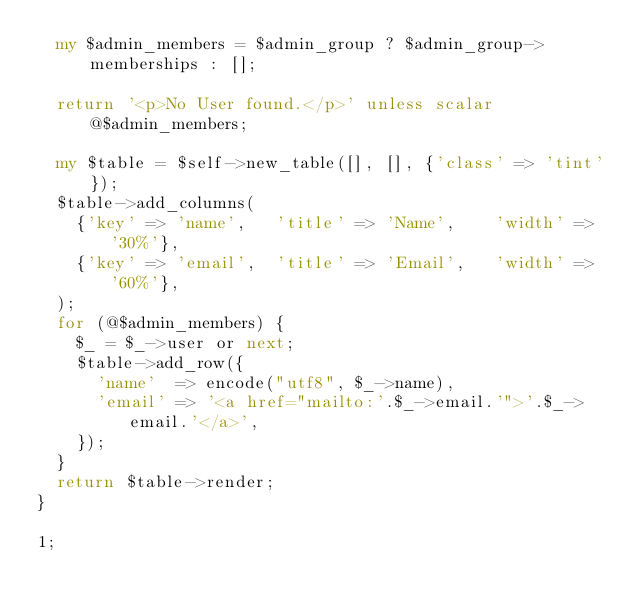Convert code to text. <code><loc_0><loc_0><loc_500><loc_500><_Perl_>  my $admin_members = $admin_group ? $admin_group->memberships : [];

  return '<p>No User found.</p>' unless scalar @$admin_members;

  my $table = $self->new_table([], [], {'class' => 'tint'});
  $table->add_columns(
    {'key' => 'name',   'title' => 'Name',    'width' => '30%'},
    {'key' => 'email',  'title' => 'Email',   'width' => '60%'},
  );
  for (@$admin_members) {
    $_ = $_->user or next;
    $table->add_row({
      'name'  => encode("utf8", $_->name),
      'email' => '<a href="mailto:'.$_->email.'">'.$_->email.'</a>',
    });
  }
  return $table->render;
}

1;</code> 